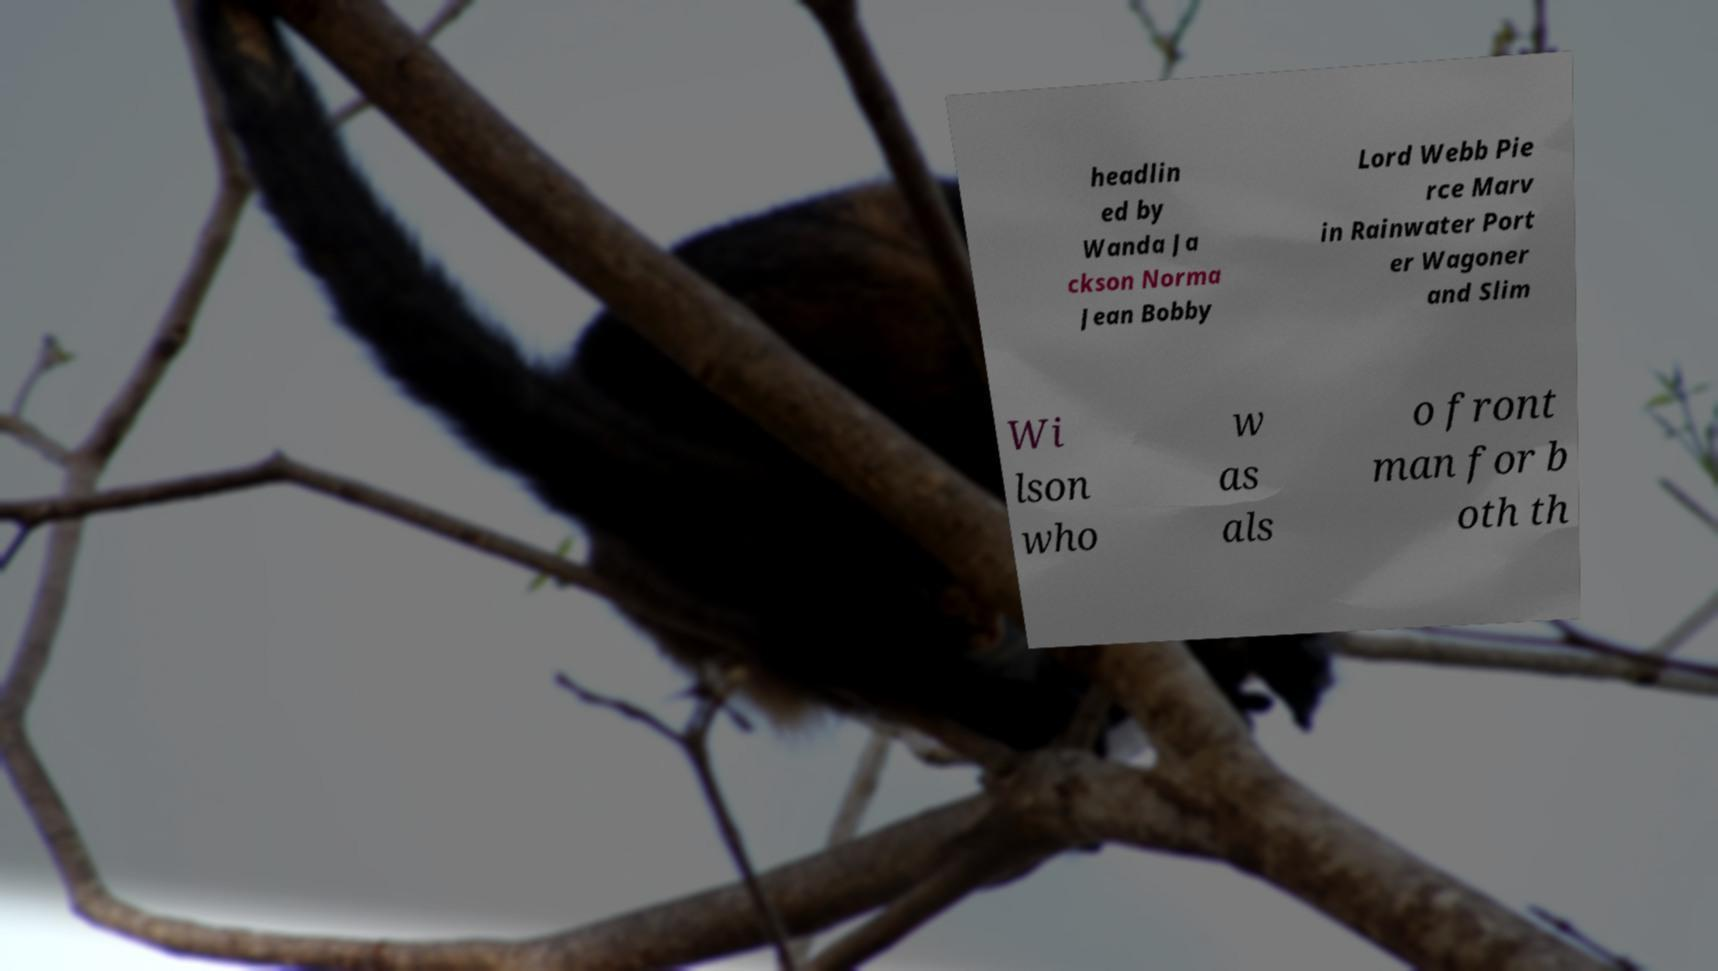Please identify and transcribe the text found in this image. headlin ed by Wanda Ja ckson Norma Jean Bobby Lord Webb Pie rce Marv in Rainwater Port er Wagoner and Slim Wi lson who w as als o front man for b oth th 